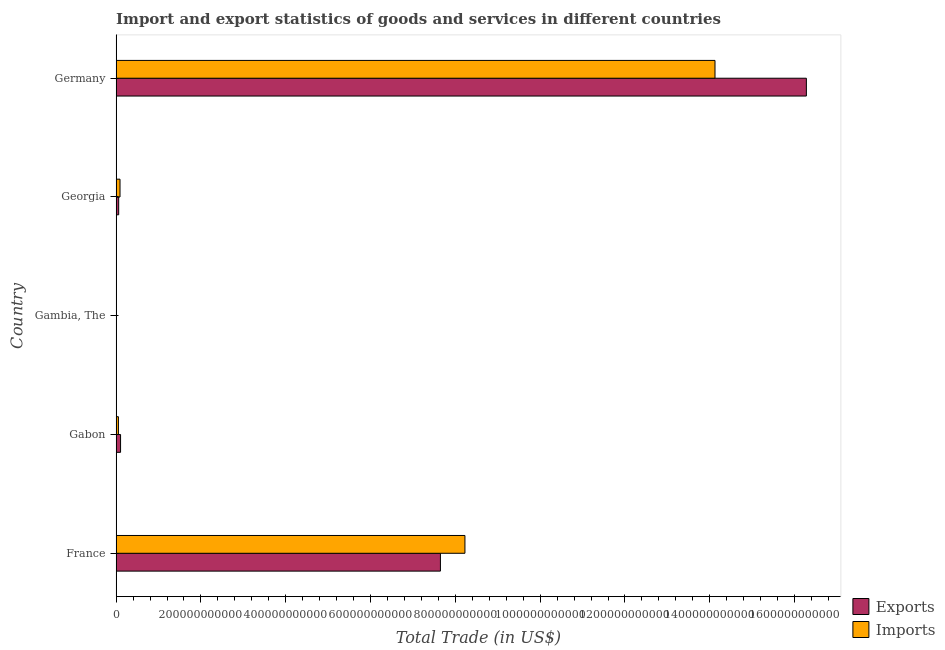Are the number of bars per tick equal to the number of legend labels?
Provide a succinct answer. Yes. What is the imports of goods and services in France?
Offer a very short reply. 8.23e+11. Across all countries, what is the maximum export of goods and services?
Make the answer very short. 1.63e+12. Across all countries, what is the minimum imports of goods and services?
Provide a succinct answer. 4.03e+08. In which country was the imports of goods and services minimum?
Your response must be concise. Gambia, The. What is the total export of goods and services in the graph?
Your response must be concise. 2.41e+12. What is the difference between the export of goods and services in France and that in Gabon?
Make the answer very short. 7.54e+11. What is the difference between the imports of goods and services in Georgia and the export of goods and services in France?
Provide a succinct answer. -7.56e+11. What is the average export of goods and services per country?
Give a very brief answer. 4.82e+11. What is the difference between the imports of goods and services and export of goods and services in Gabon?
Make the answer very short. -5.08e+09. What is the ratio of the imports of goods and services in Gabon to that in Gambia, The?
Your response must be concise. 13.38. What is the difference between the highest and the second highest imports of goods and services?
Your answer should be compact. 5.90e+11. What is the difference between the highest and the lowest export of goods and services?
Provide a succinct answer. 1.63e+12. Is the sum of the export of goods and services in Gambia, The and Georgia greater than the maximum imports of goods and services across all countries?
Provide a succinct answer. No. What does the 1st bar from the top in Germany represents?
Keep it short and to the point. Imports. What does the 1st bar from the bottom in Georgia represents?
Your response must be concise. Exports. Are all the bars in the graph horizontal?
Offer a terse response. Yes. What is the difference between two consecutive major ticks on the X-axis?
Keep it short and to the point. 2.00e+11. Are the values on the major ticks of X-axis written in scientific E-notation?
Offer a very short reply. No. Does the graph contain any zero values?
Provide a succinct answer. No. Does the graph contain grids?
Ensure brevity in your answer.  No. How are the legend labels stacked?
Provide a succinct answer. Vertical. What is the title of the graph?
Your response must be concise. Import and export statistics of goods and services in different countries. Does "Registered firms" appear as one of the legend labels in the graph?
Your answer should be compact. No. What is the label or title of the X-axis?
Keep it short and to the point. Total Trade (in US$). What is the Total Trade (in US$) in Exports in France?
Make the answer very short. 7.65e+11. What is the Total Trade (in US$) of Imports in France?
Ensure brevity in your answer.  8.23e+11. What is the Total Trade (in US$) in Exports in Gabon?
Your response must be concise. 1.05e+1. What is the Total Trade (in US$) in Imports in Gabon?
Your answer should be compact. 5.39e+09. What is the Total Trade (in US$) of Exports in Gambia, The?
Keep it short and to the point. 2.81e+08. What is the Total Trade (in US$) of Imports in Gambia, The?
Provide a short and direct response. 4.03e+08. What is the Total Trade (in US$) in Exports in Georgia?
Your answer should be compact. 6.05e+09. What is the Total Trade (in US$) in Imports in Georgia?
Your answer should be compact. 9.16e+09. What is the Total Trade (in US$) of Exports in Germany?
Keep it short and to the point. 1.63e+12. What is the Total Trade (in US$) in Imports in Germany?
Your answer should be compact. 1.41e+12. Across all countries, what is the maximum Total Trade (in US$) of Exports?
Offer a terse response. 1.63e+12. Across all countries, what is the maximum Total Trade (in US$) of Imports?
Ensure brevity in your answer.  1.41e+12. Across all countries, what is the minimum Total Trade (in US$) of Exports?
Your answer should be compact. 2.81e+08. Across all countries, what is the minimum Total Trade (in US$) of Imports?
Give a very brief answer. 4.03e+08. What is the total Total Trade (in US$) of Exports in the graph?
Your answer should be compact. 2.41e+12. What is the total Total Trade (in US$) of Imports in the graph?
Your answer should be compact. 2.25e+12. What is the difference between the Total Trade (in US$) of Exports in France and that in Gabon?
Keep it short and to the point. 7.54e+11. What is the difference between the Total Trade (in US$) in Imports in France and that in Gabon?
Make the answer very short. 8.17e+11. What is the difference between the Total Trade (in US$) in Exports in France and that in Gambia, The?
Provide a succinct answer. 7.65e+11. What is the difference between the Total Trade (in US$) of Imports in France and that in Gambia, The?
Your answer should be very brief. 8.22e+11. What is the difference between the Total Trade (in US$) in Exports in France and that in Georgia?
Keep it short and to the point. 7.59e+11. What is the difference between the Total Trade (in US$) of Imports in France and that in Georgia?
Provide a short and direct response. 8.13e+11. What is the difference between the Total Trade (in US$) of Exports in France and that in Germany?
Ensure brevity in your answer.  -8.63e+11. What is the difference between the Total Trade (in US$) of Imports in France and that in Germany?
Provide a short and direct response. -5.90e+11. What is the difference between the Total Trade (in US$) in Exports in Gabon and that in Gambia, The?
Provide a succinct answer. 1.02e+1. What is the difference between the Total Trade (in US$) of Imports in Gabon and that in Gambia, The?
Keep it short and to the point. 4.99e+09. What is the difference between the Total Trade (in US$) of Exports in Gabon and that in Georgia?
Ensure brevity in your answer.  4.42e+09. What is the difference between the Total Trade (in US$) in Imports in Gabon and that in Georgia?
Keep it short and to the point. -3.77e+09. What is the difference between the Total Trade (in US$) of Exports in Gabon and that in Germany?
Ensure brevity in your answer.  -1.62e+12. What is the difference between the Total Trade (in US$) in Imports in Gabon and that in Germany?
Offer a very short reply. -1.41e+12. What is the difference between the Total Trade (in US$) in Exports in Gambia, The and that in Georgia?
Your answer should be compact. -5.76e+09. What is the difference between the Total Trade (in US$) of Imports in Gambia, The and that in Georgia?
Make the answer very short. -8.76e+09. What is the difference between the Total Trade (in US$) in Exports in Gambia, The and that in Germany?
Make the answer very short. -1.63e+12. What is the difference between the Total Trade (in US$) of Imports in Gambia, The and that in Germany?
Give a very brief answer. -1.41e+12. What is the difference between the Total Trade (in US$) of Exports in Georgia and that in Germany?
Provide a succinct answer. -1.62e+12. What is the difference between the Total Trade (in US$) of Imports in Georgia and that in Germany?
Provide a short and direct response. -1.40e+12. What is the difference between the Total Trade (in US$) in Exports in France and the Total Trade (in US$) in Imports in Gabon?
Provide a succinct answer. 7.59e+11. What is the difference between the Total Trade (in US$) in Exports in France and the Total Trade (in US$) in Imports in Gambia, The?
Make the answer very short. 7.64e+11. What is the difference between the Total Trade (in US$) of Exports in France and the Total Trade (in US$) of Imports in Georgia?
Your answer should be compact. 7.56e+11. What is the difference between the Total Trade (in US$) of Exports in France and the Total Trade (in US$) of Imports in Germany?
Ensure brevity in your answer.  -6.48e+11. What is the difference between the Total Trade (in US$) in Exports in Gabon and the Total Trade (in US$) in Imports in Gambia, The?
Give a very brief answer. 1.01e+1. What is the difference between the Total Trade (in US$) in Exports in Gabon and the Total Trade (in US$) in Imports in Georgia?
Provide a succinct answer. 1.31e+09. What is the difference between the Total Trade (in US$) in Exports in Gabon and the Total Trade (in US$) in Imports in Germany?
Provide a short and direct response. -1.40e+12. What is the difference between the Total Trade (in US$) of Exports in Gambia, The and the Total Trade (in US$) of Imports in Georgia?
Provide a succinct answer. -8.88e+09. What is the difference between the Total Trade (in US$) of Exports in Gambia, The and the Total Trade (in US$) of Imports in Germany?
Offer a terse response. -1.41e+12. What is the difference between the Total Trade (in US$) of Exports in Georgia and the Total Trade (in US$) of Imports in Germany?
Provide a short and direct response. -1.41e+12. What is the average Total Trade (in US$) of Exports per country?
Provide a short and direct response. 4.82e+11. What is the average Total Trade (in US$) in Imports per country?
Your answer should be very brief. 4.50e+11. What is the difference between the Total Trade (in US$) in Exports and Total Trade (in US$) in Imports in France?
Your response must be concise. -5.78e+1. What is the difference between the Total Trade (in US$) in Exports and Total Trade (in US$) in Imports in Gabon?
Your answer should be compact. 5.08e+09. What is the difference between the Total Trade (in US$) in Exports and Total Trade (in US$) in Imports in Gambia, The?
Provide a succinct answer. -1.22e+08. What is the difference between the Total Trade (in US$) in Exports and Total Trade (in US$) in Imports in Georgia?
Your response must be concise. -3.11e+09. What is the difference between the Total Trade (in US$) in Exports and Total Trade (in US$) in Imports in Germany?
Offer a very short reply. 2.15e+11. What is the ratio of the Total Trade (in US$) in Exports in France to that in Gabon?
Make the answer very short. 73.07. What is the ratio of the Total Trade (in US$) in Imports in France to that in Gabon?
Your answer should be very brief. 152.61. What is the ratio of the Total Trade (in US$) of Exports in France to that in Gambia, The?
Provide a short and direct response. 2723.98. What is the ratio of the Total Trade (in US$) in Imports in France to that in Gambia, The?
Your answer should be compact. 2041.57. What is the ratio of the Total Trade (in US$) in Exports in France to that in Georgia?
Ensure brevity in your answer.  126.51. What is the ratio of the Total Trade (in US$) of Imports in France to that in Georgia?
Provide a short and direct response. 89.82. What is the ratio of the Total Trade (in US$) of Exports in France to that in Germany?
Keep it short and to the point. 0.47. What is the ratio of the Total Trade (in US$) of Imports in France to that in Germany?
Make the answer very short. 0.58. What is the ratio of the Total Trade (in US$) in Exports in Gabon to that in Gambia, The?
Give a very brief answer. 37.28. What is the ratio of the Total Trade (in US$) in Imports in Gabon to that in Gambia, The?
Offer a terse response. 13.38. What is the ratio of the Total Trade (in US$) of Exports in Gabon to that in Georgia?
Your answer should be very brief. 1.73. What is the ratio of the Total Trade (in US$) of Imports in Gabon to that in Georgia?
Provide a short and direct response. 0.59. What is the ratio of the Total Trade (in US$) in Exports in Gabon to that in Germany?
Give a very brief answer. 0.01. What is the ratio of the Total Trade (in US$) in Imports in Gabon to that in Germany?
Ensure brevity in your answer.  0. What is the ratio of the Total Trade (in US$) in Exports in Gambia, The to that in Georgia?
Your answer should be compact. 0.05. What is the ratio of the Total Trade (in US$) of Imports in Gambia, The to that in Georgia?
Keep it short and to the point. 0.04. What is the ratio of the Total Trade (in US$) of Exports in Georgia to that in Germany?
Make the answer very short. 0. What is the ratio of the Total Trade (in US$) of Imports in Georgia to that in Germany?
Your answer should be very brief. 0.01. What is the difference between the highest and the second highest Total Trade (in US$) of Exports?
Your response must be concise. 8.63e+11. What is the difference between the highest and the second highest Total Trade (in US$) in Imports?
Keep it short and to the point. 5.90e+11. What is the difference between the highest and the lowest Total Trade (in US$) in Exports?
Provide a short and direct response. 1.63e+12. What is the difference between the highest and the lowest Total Trade (in US$) of Imports?
Make the answer very short. 1.41e+12. 